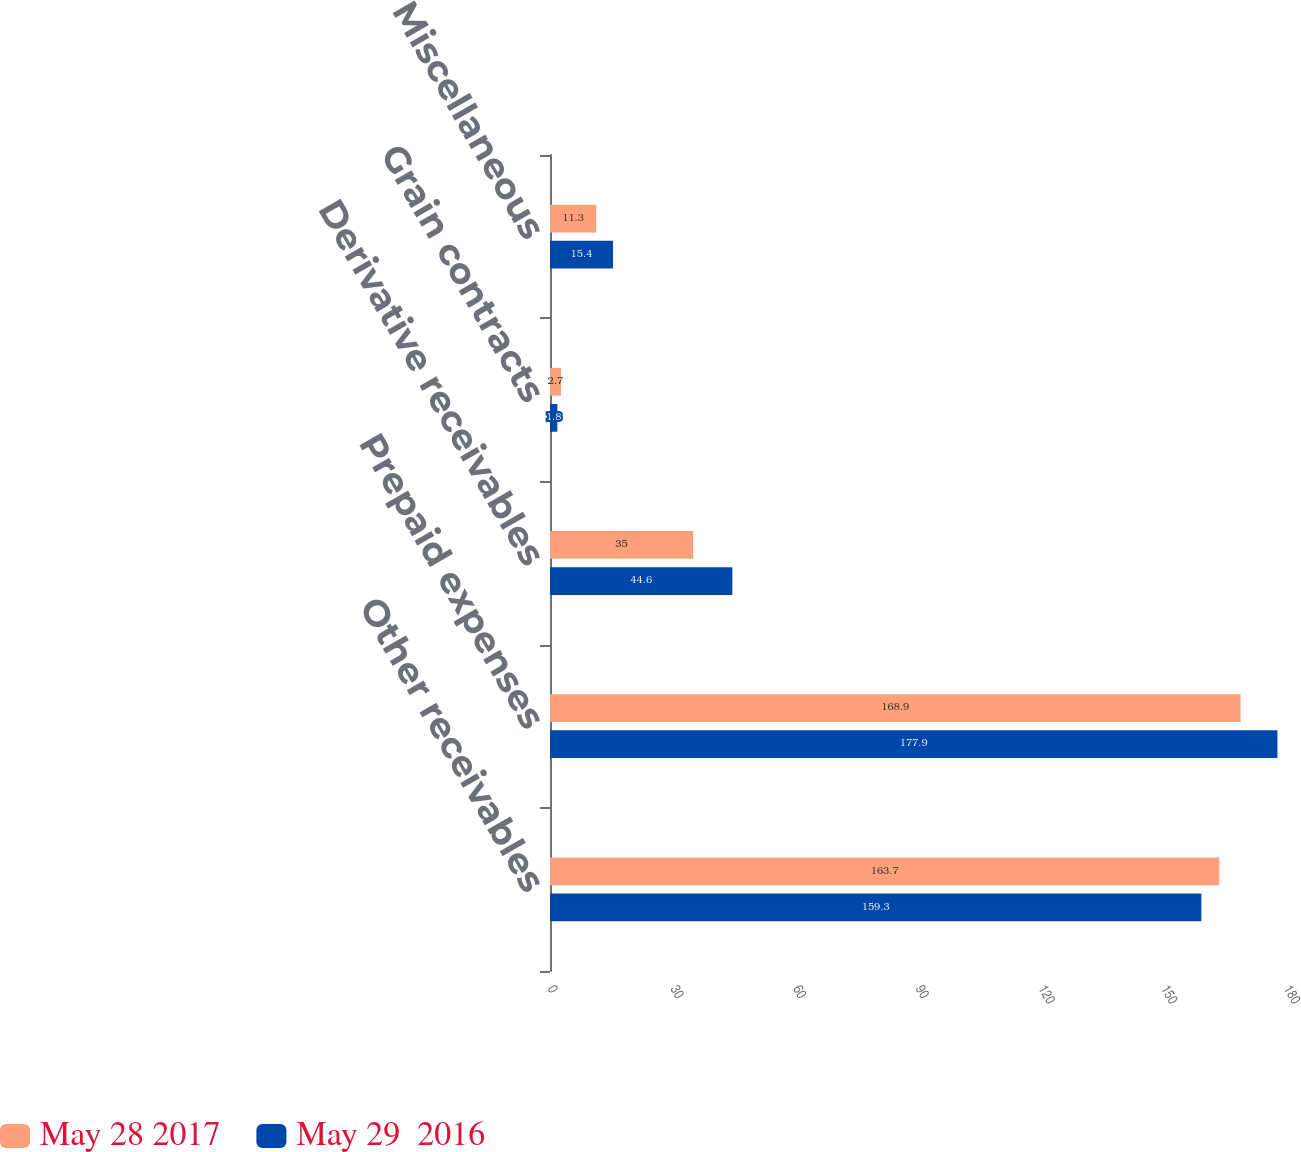Convert chart. <chart><loc_0><loc_0><loc_500><loc_500><stacked_bar_chart><ecel><fcel>Other receivables<fcel>Prepaid expenses<fcel>Derivative receivables<fcel>Grain contracts<fcel>Miscellaneous<nl><fcel>May 28 2017<fcel>163.7<fcel>168.9<fcel>35<fcel>2.7<fcel>11.3<nl><fcel>May 29  2016<fcel>159.3<fcel>177.9<fcel>44.6<fcel>1.8<fcel>15.4<nl></chart> 